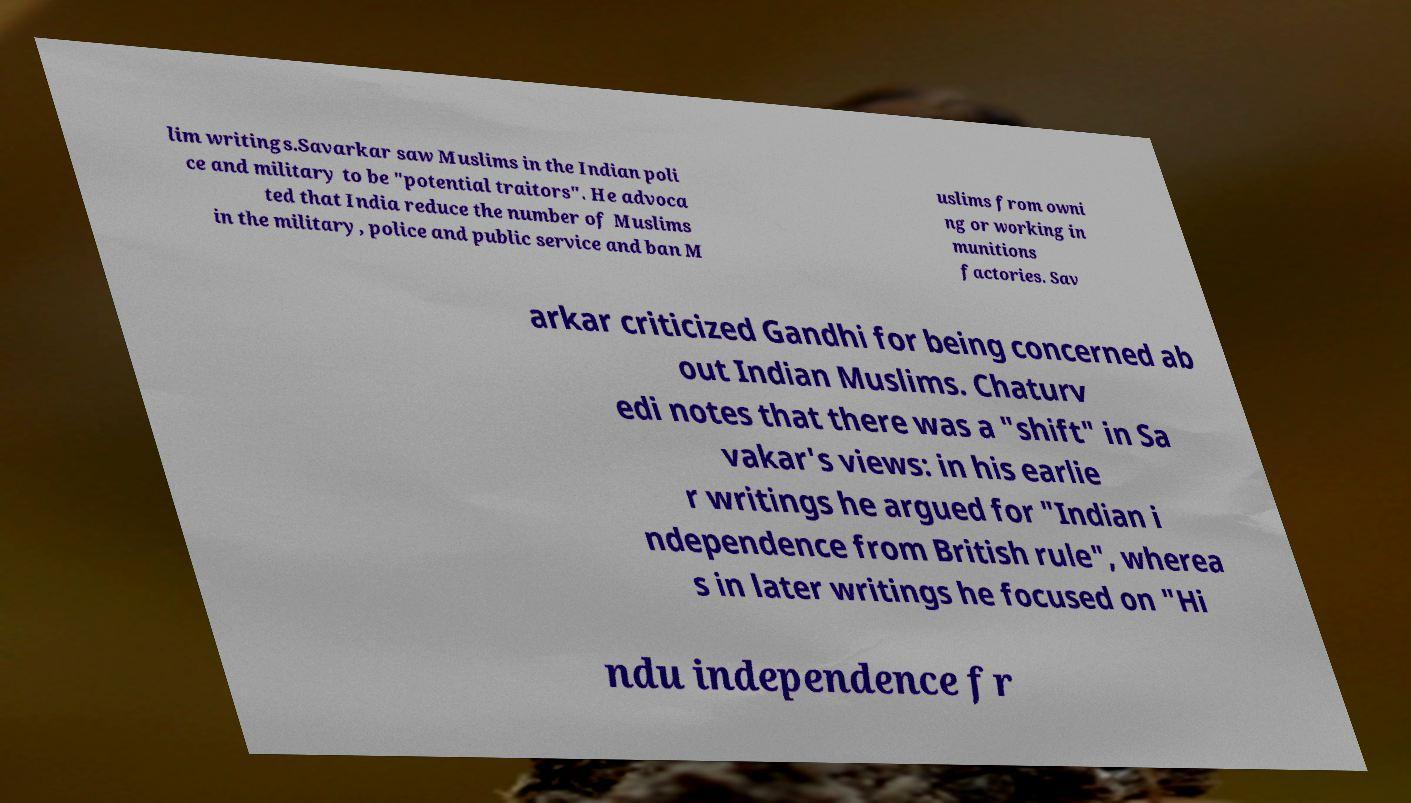There's text embedded in this image that I need extracted. Can you transcribe it verbatim? lim writings.Savarkar saw Muslims in the Indian poli ce and military to be "potential traitors". He advoca ted that India reduce the number of Muslims in the military, police and public service and ban M uslims from owni ng or working in munitions factories. Sav arkar criticized Gandhi for being concerned ab out Indian Muslims. Chaturv edi notes that there was a "shift" in Sa vakar's views: in his earlie r writings he argued for "Indian i ndependence from British rule", wherea s in later writings he focused on "Hi ndu independence fr 